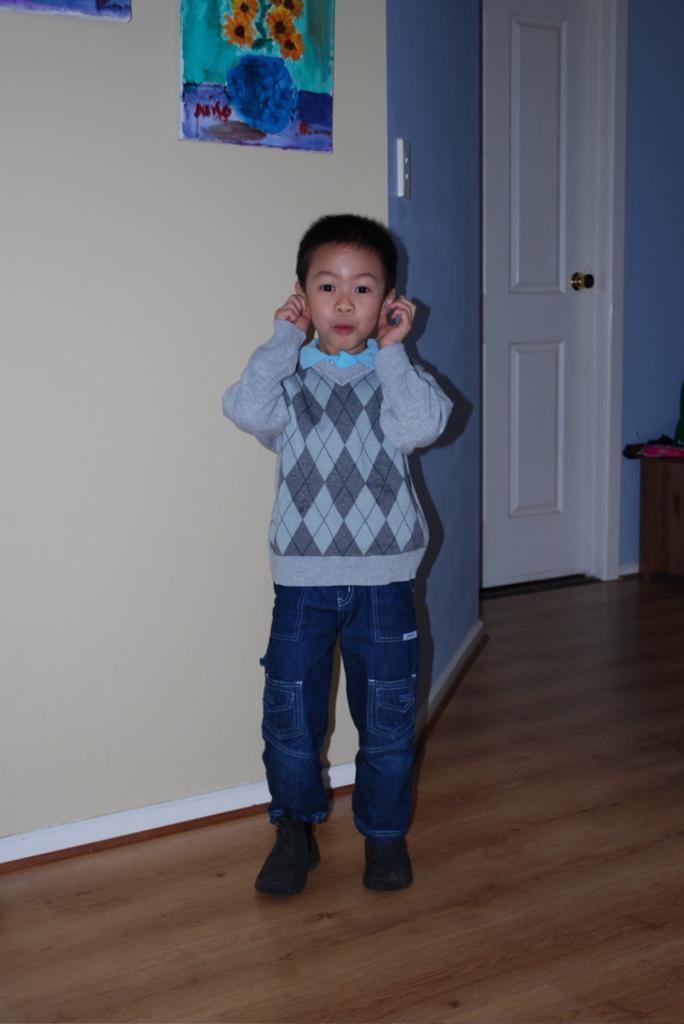How would you summarize this image in a sentence or two? In this image I see a boy who is standing and I see that he is holding ears with his hands and I see the floor. In the background I see the wall which is of white and blue in color and I see the papers on which there are paintings and I see the white door over here. 